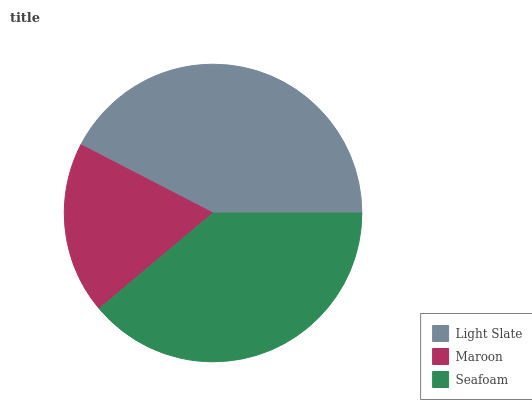Is Maroon the minimum?
Answer yes or no. Yes. Is Light Slate the maximum?
Answer yes or no. Yes. Is Seafoam the minimum?
Answer yes or no. No. Is Seafoam the maximum?
Answer yes or no. No. Is Seafoam greater than Maroon?
Answer yes or no. Yes. Is Maroon less than Seafoam?
Answer yes or no. Yes. Is Maroon greater than Seafoam?
Answer yes or no. No. Is Seafoam less than Maroon?
Answer yes or no. No. Is Seafoam the high median?
Answer yes or no. Yes. Is Seafoam the low median?
Answer yes or no. Yes. Is Light Slate the high median?
Answer yes or no. No. Is Light Slate the low median?
Answer yes or no. No. 